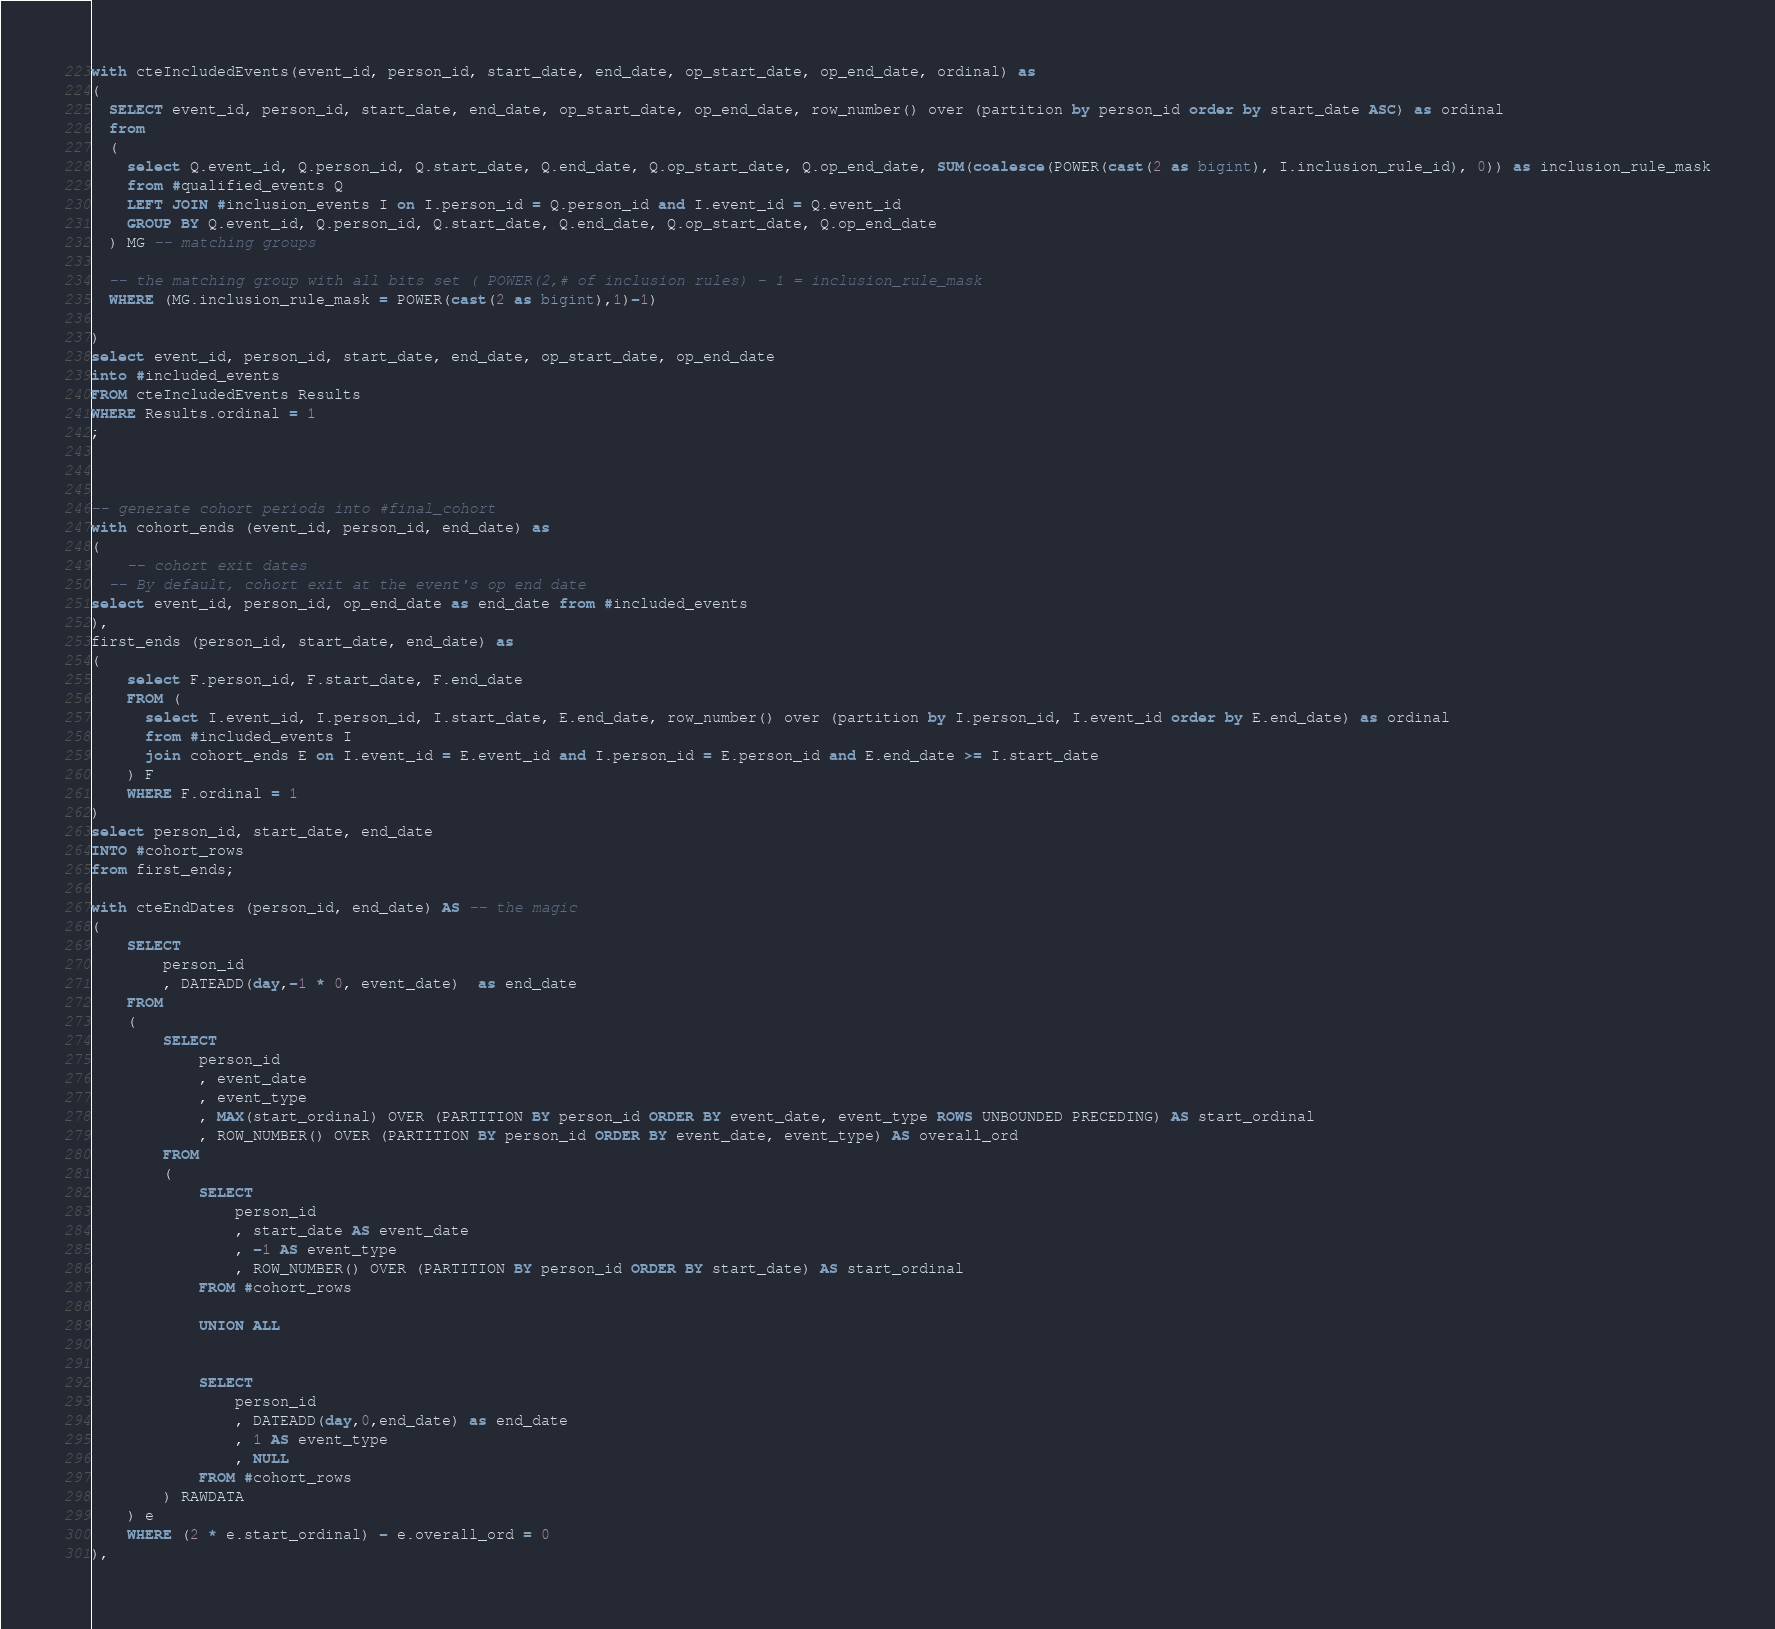<code> <loc_0><loc_0><loc_500><loc_500><_SQL_>with cteIncludedEvents(event_id, person_id, start_date, end_date, op_start_date, op_end_date, ordinal) as
(
  SELECT event_id, person_id, start_date, end_date, op_start_date, op_end_date, row_number() over (partition by person_id order by start_date ASC) as ordinal
  from
  (
    select Q.event_id, Q.person_id, Q.start_date, Q.end_date, Q.op_start_date, Q.op_end_date, SUM(coalesce(POWER(cast(2 as bigint), I.inclusion_rule_id), 0)) as inclusion_rule_mask
    from #qualified_events Q
    LEFT JOIN #inclusion_events I on I.person_id = Q.person_id and I.event_id = Q.event_id
    GROUP BY Q.event_id, Q.person_id, Q.start_date, Q.end_date, Q.op_start_date, Q.op_end_date
  ) MG -- matching groups

  -- the matching group with all bits set ( POWER(2,# of inclusion rules) - 1 = inclusion_rule_mask
  WHERE (MG.inclusion_rule_mask = POWER(cast(2 as bigint),1)-1)

)
select event_id, person_id, start_date, end_date, op_start_date, op_end_date
into #included_events
FROM cteIncludedEvents Results
WHERE Results.ordinal = 1
;



-- generate cohort periods into #final_cohort
with cohort_ends (event_id, person_id, end_date) as
(
	-- cohort exit dates
  -- By default, cohort exit at the event's op end date
select event_id, person_id, op_end_date as end_date from #included_events
),
first_ends (person_id, start_date, end_date) as
(
	select F.person_id, F.start_date, F.end_date
	FROM (
	  select I.event_id, I.person_id, I.start_date, E.end_date, row_number() over (partition by I.person_id, I.event_id order by E.end_date) as ordinal 
	  from #included_events I
	  join cohort_ends E on I.event_id = E.event_id and I.person_id = E.person_id and E.end_date >= I.start_date
	) F
	WHERE F.ordinal = 1
)
select person_id, start_date, end_date
INTO #cohort_rows
from first_ends;

with cteEndDates (person_id, end_date) AS -- the magic
(	
	SELECT
		person_id
		, DATEADD(day,-1 * 0, event_date)  as end_date
	FROM
	(
		SELECT
			person_id
			, event_date
			, event_type
			, MAX(start_ordinal) OVER (PARTITION BY person_id ORDER BY event_date, event_type ROWS UNBOUNDED PRECEDING) AS start_ordinal 
			, ROW_NUMBER() OVER (PARTITION BY person_id ORDER BY event_date, event_type) AS overall_ord
		FROM
		(
			SELECT
				person_id
				, start_date AS event_date
				, -1 AS event_type
				, ROW_NUMBER() OVER (PARTITION BY person_id ORDER BY start_date) AS start_ordinal
			FROM #cohort_rows
		
			UNION ALL
		

			SELECT
				person_id
				, DATEADD(day,0,end_date) as end_date
				, 1 AS event_type
				, NULL
			FROM #cohort_rows
		) RAWDATA
	) e
	WHERE (2 * e.start_ordinal) - e.overall_ord = 0
),</code> 